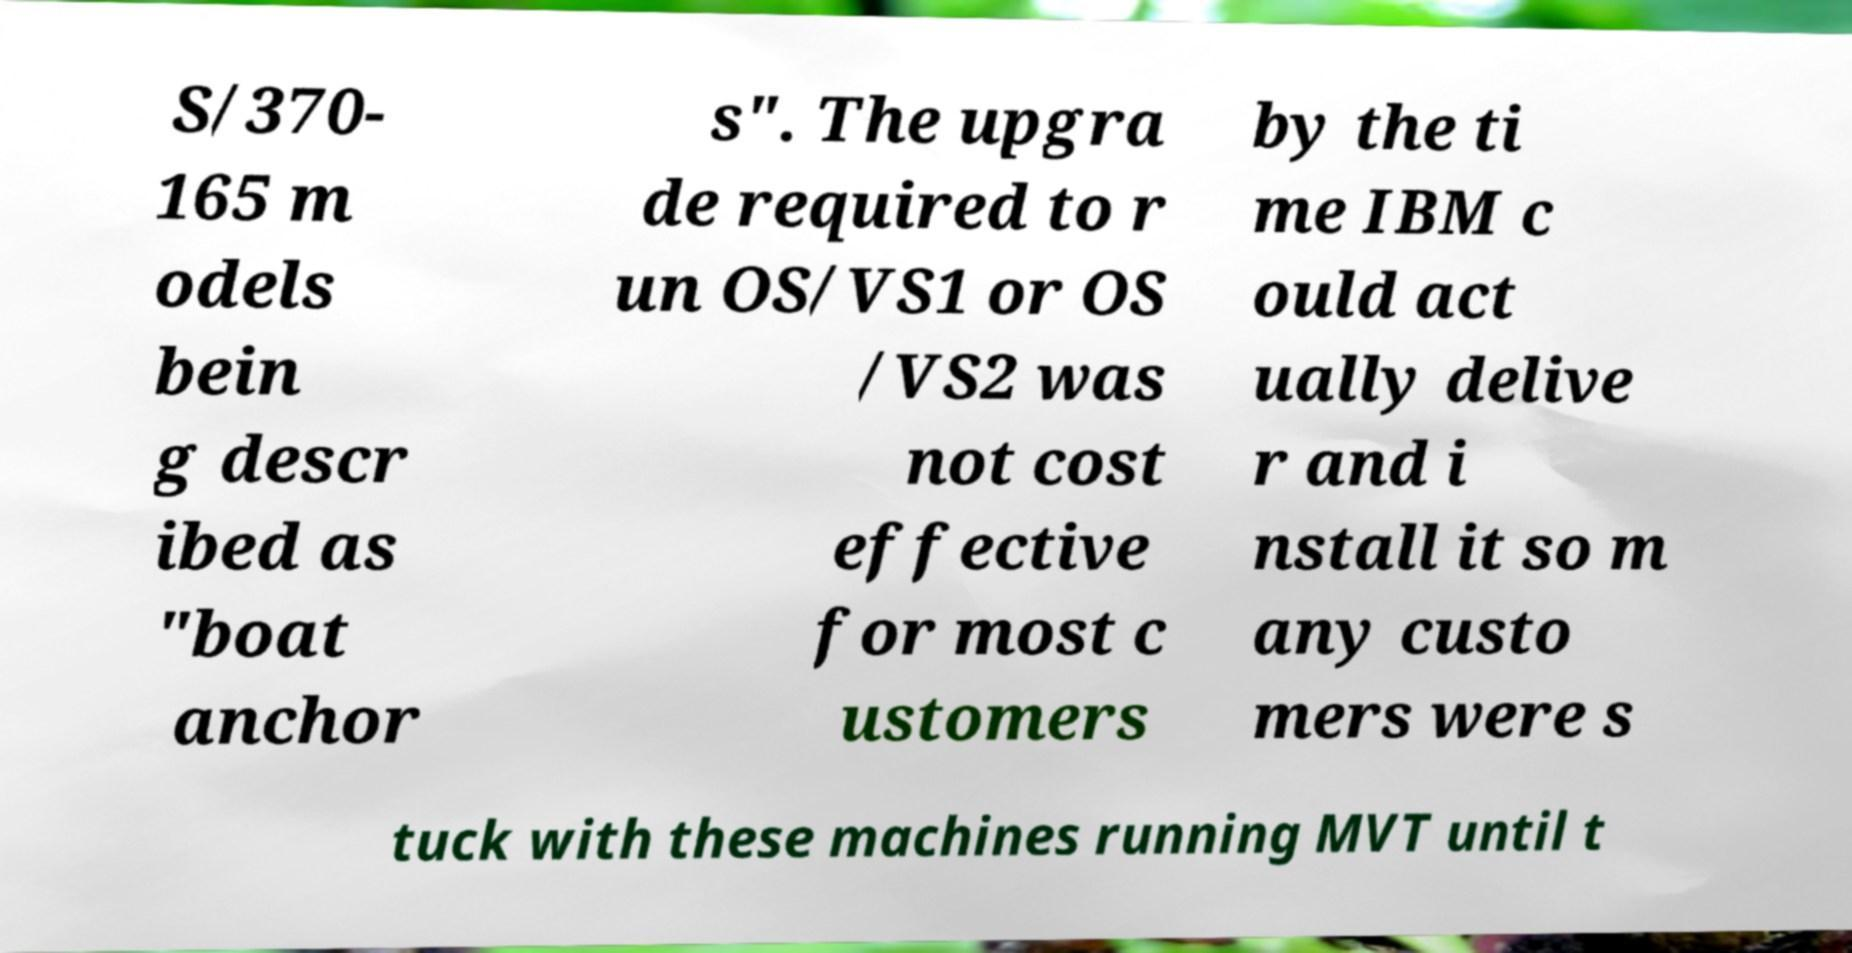Can you read and provide the text displayed in the image?This photo seems to have some interesting text. Can you extract and type it out for me? S/370- 165 m odels bein g descr ibed as "boat anchor s". The upgra de required to r un OS/VS1 or OS /VS2 was not cost effective for most c ustomers by the ti me IBM c ould act ually delive r and i nstall it so m any custo mers were s tuck with these machines running MVT until t 